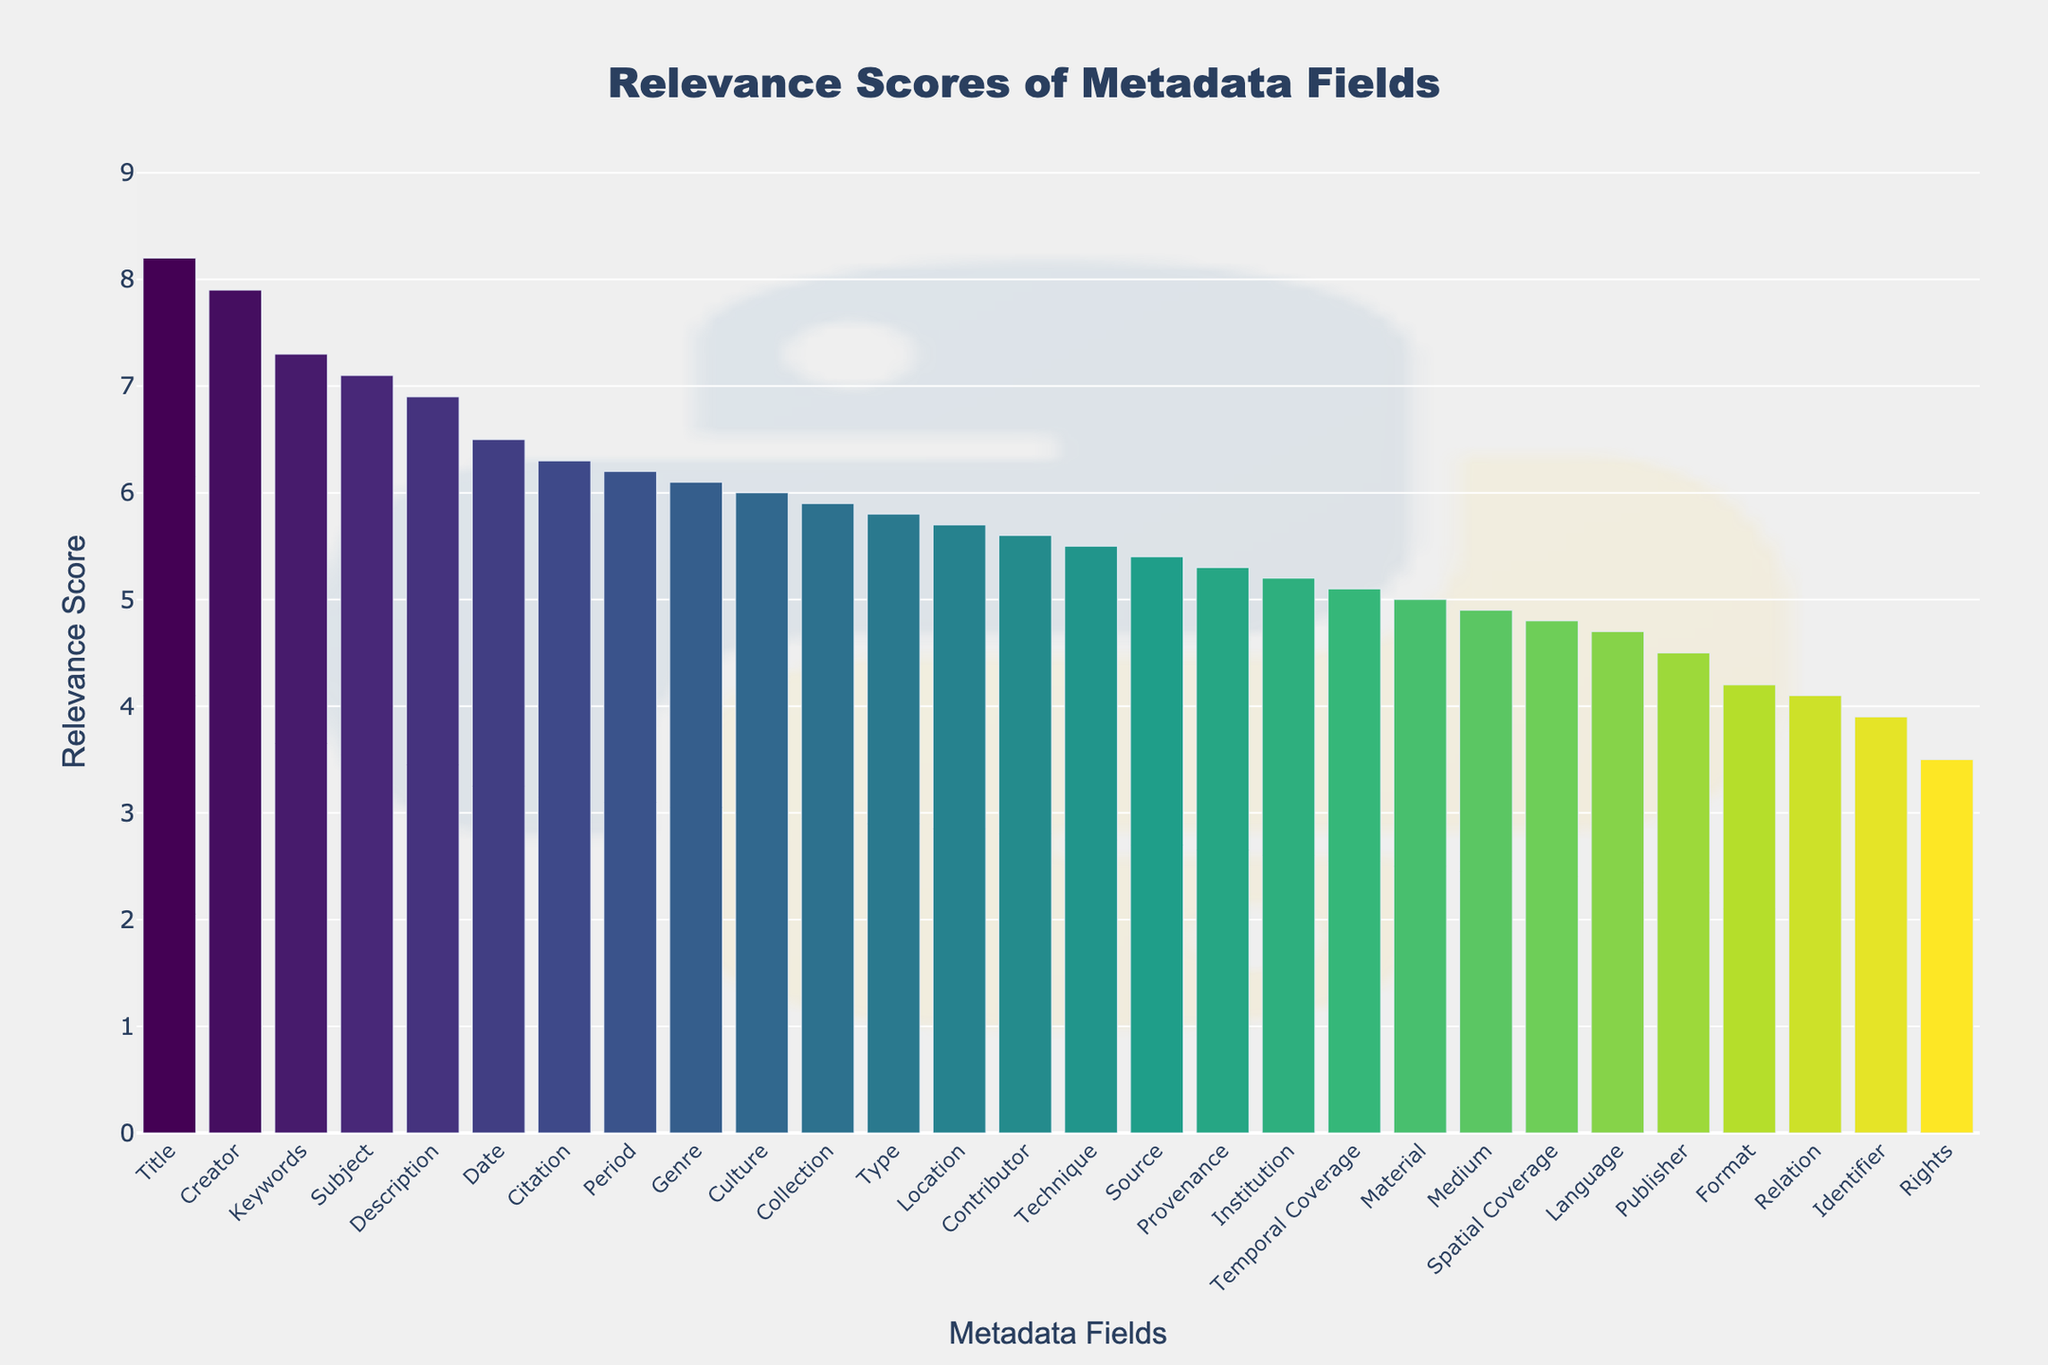What is the title of the chart? The title is prominently displayed at the top of the chart. By reading it, we can identify its purpose.
Answer: Relevance Scores of Metadata Fields What is the highest relevance score and which metadata field does it belong to? By looking at the bar with the greatest height, which represents the highest relevance score, we can identify the corresponding metadata field from the x-axis.
Answer: Title, 8.2 Which metadata fields have scores greater than 7.0? By identifying the bars that exceed the 7.0 mark on the y-axis, we can read off the metadata fields from the x-axis ticks.
Answer: Title, Creator, Subject, Keywords What is the relevance score of the 'Description' metadata field? Locate the 'Description' field on the x-axis and check the height of the corresponding bar to read its exact value.
Answer: 6.9 How many metadata fields have a score below 5.0? By visually counting all the bars that do not reach the 5.0 mark on the y-axis, we can determine the number of those fields.
Answer: 6 Which has a higher relevance score, 'Language' or 'Spatial Coverage'? Compare the heights of the bars for the 'Language' and 'Spatial Coverage' fields to see which one is taller.
Answer: Spatial Coverage Which metadata field has the lowest relevance score? Identify the bar with the shortest height, which indicates the lowest score, and read the corresponding field on the x-axis.
Answer: Rights 